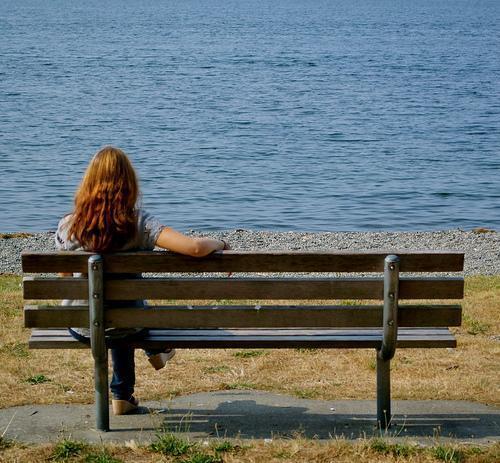How many girls are there?
Give a very brief answer. 1. 